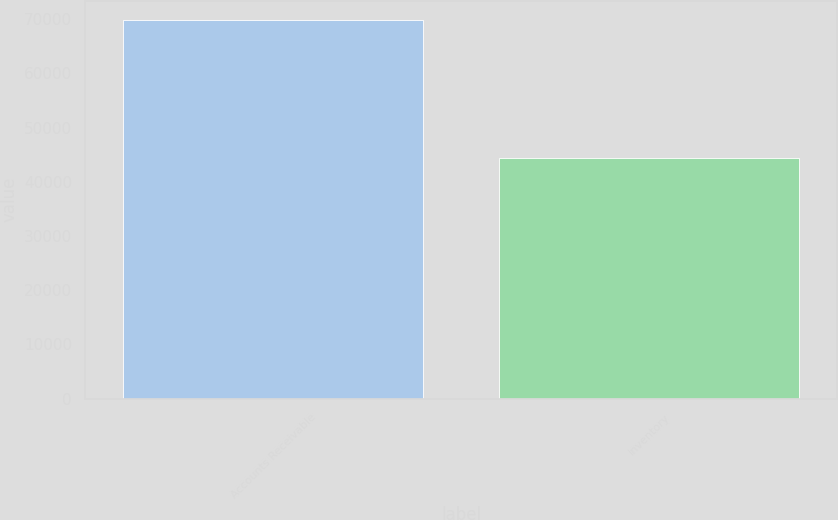Convert chart to OTSL. <chart><loc_0><loc_0><loc_500><loc_500><bar_chart><fcel>Accounts Receivable<fcel>Inventory<nl><fcel>69922<fcel>44387<nl></chart> 